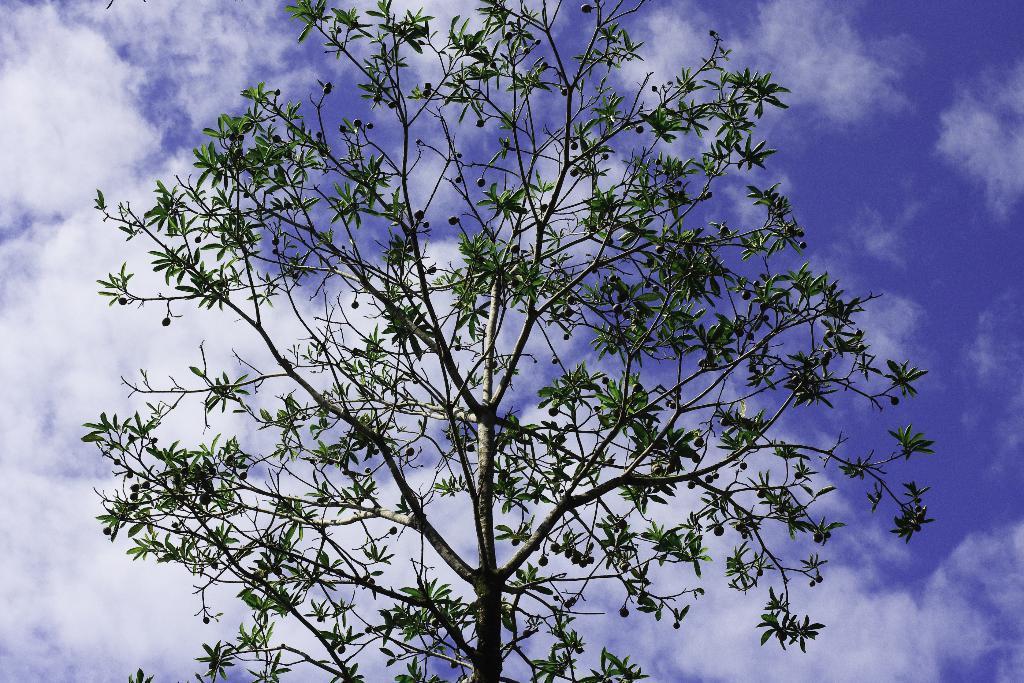Please provide a concise description of this image. In the image I can see a tree to which there are some raw fruits and also I can see some clouds to the sky. 